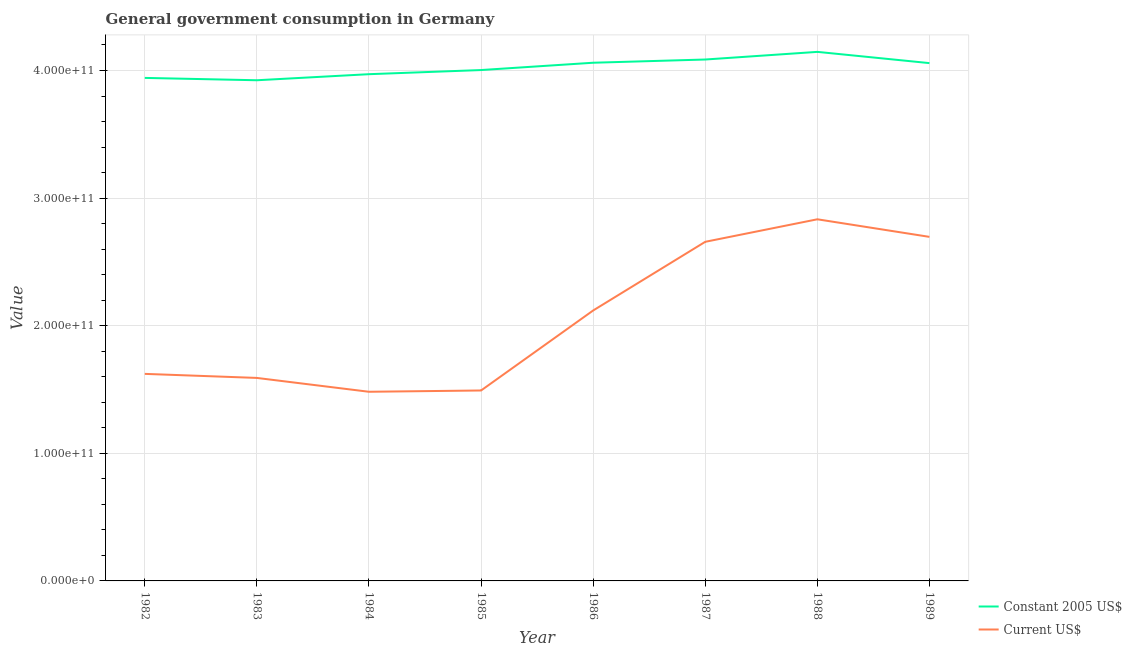Does the line corresponding to value consumed in current us$ intersect with the line corresponding to value consumed in constant 2005 us$?
Your answer should be compact. No. What is the value consumed in current us$ in 1982?
Provide a short and direct response. 1.62e+11. Across all years, what is the maximum value consumed in current us$?
Provide a short and direct response. 2.83e+11. Across all years, what is the minimum value consumed in constant 2005 us$?
Provide a short and direct response. 3.92e+11. What is the total value consumed in current us$ in the graph?
Make the answer very short. 1.65e+12. What is the difference between the value consumed in constant 2005 us$ in 1985 and that in 1986?
Your response must be concise. -5.73e+09. What is the difference between the value consumed in constant 2005 us$ in 1989 and the value consumed in current us$ in 1988?
Your answer should be very brief. 1.22e+11. What is the average value consumed in current us$ per year?
Provide a short and direct response. 2.06e+11. In the year 1986, what is the difference between the value consumed in constant 2005 us$ and value consumed in current us$?
Give a very brief answer. 1.94e+11. What is the ratio of the value consumed in constant 2005 us$ in 1985 to that in 1986?
Provide a short and direct response. 0.99. What is the difference between the highest and the second highest value consumed in current us$?
Provide a succinct answer. 1.38e+1. What is the difference between the highest and the lowest value consumed in current us$?
Your answer should be compact. 1.35e+11. In how many years, is the value consumed in constant 2005 us$ greater than the average value consumed in constant 2005 us$ taken over all years?
Offer a terse response. 4. Is the sum of the value consumed in constant 2005 us$ in 1982 and 1989 greater than the maximum value consumed in current us$ across all years?
Offer a terse response. Yes. How many lines are there?
Offer a very short reply. 2. What is the difference between two consecutive major ticks on the Y-axis?
Give a very brief answer. 1.00e+11. Are the values on the major ticks of Y-axis written in scientific E-notation?
Make the answer very short. Yes. Does the graph contain any zero values?
Provide a succinct answer. No. Where does the legend appear in the graph?
Offer a very short reply. Bottom right. What is the title of the graph?
Your response must be concise. General government consumption in Germany. What is the label or title of the Y-axis?
Provide a succinct answer. Value. What is the Value in Constant 2005 US$ in 1982?
Give a very brief answer. 3.94e+11. What is the Value in Current US$ in 1982?
Your answer should be very brief. 1.62e+11. What is the Value in Constant 2005 US$ in 1983?
Ensure brevity in your answer.  3.92e+11. What is the Value of Current US$ in 1983?
Make the answer very short. 1.59e+11. What is the Value of Constant 2005 US$ in 1984?
Your response must be concise. 3.97e+11. What is the Value in Current US$ in 1984?
Offer a terse response. 1.48e+11. What is the Value in Constant 2005 US$ in 1985?
Ensure brevity in your answer.  4.00e+11. What is the Value of Current US$ in 1985?
Ensure brevity in your answer.  1.49e+11. What is the Value in Constant 2005 US$ in 1986?
Your response must be concise. 4.06e+11. What is the Value in Current US$ in 1986?
Provide a succinct answer. 2.12e+11. What is the Value in Constant 2005 US$ in 1987?
Offer a terse response. 4.09e+11. What is the Value in Current US$ in 1987?
Ensure brevity in your answer.  2.66e+11. What is the Value of Constant 2005 US$ in 1988?
Keep it short and to the point. 4.15e+11. What is the Value in Current US$ in 1988?
Ensure brevity in your answer.  2.83e+11. What is the Value in Constant 2005 US$ in 1989?
Provide a short and direct response. 4.06e+11. What is the Value of Current US$ in 1989?
Give a very brief answer. 2.70e+11. Across all years, what is the maximum Value of Constant 2005 US$?
Your answer should be compact. 4.15e+11. Across all years, what is the maximum Value in Current US$?
Offer a very short reply. 2.83e+11. Across all years, what is the minimum Value of Constant 2005 US$?
Offer a terse response. 3.92e+11. Across all years, what is the minimum Value in Current US$?
Make the answer very short. 1.48e+11. What is the total Value in Constant 2005 US$ in the graph?
Offer a very short reply. 3.22e+12. What is the total Value in Current US$ in the graph?
Your answer should be very brief. 1.65e+12. What is the difference between the Value of Constant 2005 US$ in 1982 and that in 1983?
Your response must be concise. 1.84e+09. What is the difference between the Value in Current US$ in 1982 and that in 1983?
Provide a short and direct response. 3.17e+09. What is the difference between the Value of Constant 2005 US$ in 1982 and that in 1984?
Provide a short and direct response. -2.91e+09. What is the difference between the Value in Current US$ in 1982 and that in 1984?
Your answer should be compact. 1.40e+1. What is the difference between the Value of Constant 2005 US$ in 1982 and that in 1985?
Provide a succinct answer. -6.16e+09. What is the difference between the Value in Current US$ in 1982 and that in 1985?
Provide a short and direct response. 1.30e+1. What is the difference between the Value of Constant 2005 US$ in 1982 and that in 1986?
Make the answer very short. -1.19e+1. What is the difference between the Value of Current US$ in 1982 and that in 1986?
Offer a very short reply. -4.97e+1. What is the difference between the Value in Constant 2005 US$ in 1982 and that in 1987?
Your answer should be very brief. -1.44e+1. What is the difference between the Value in Current US$ in 1982 and that in 1987?
Provide a short and direct response. -1.03e+11. What is the difference between the Value of Constant 2005 US$ in 1982 and that in 1988?
Offer a very short reply. -2.04e+1. What is the difference between the Value in Current US$ in 1982 and that in 1988?
Keep it short and to the point. -1.21e+11. What is the difference between the Value of Constant 2005 US$ in 1982 and that in 1989?
Your answer should be compact. -1.16e+1. What is the difference between the Value in Current US$ in 1982 and that in 1989?
Your answer should be compact. -1.07e+11. What is the difference between the Value in Constant 2005 US$ in 1983 and that in 1984?
Your answer should be very brief. -4.75e+09. What is the difference between the Value of Current US$ in 1983 and that in 1984?
Keep it short and to the point. 1.09e+1. What is the difference between the Value of Constant 2005 US$ in 1983 and that in 1985?
Your answer should be compact. -8.00e+09. What is the difference between the Value in Current US$ in 1983 and that in 1985?
Make the answer very short. 9.84e+09. What is the difference between the Value in Constant 2005 US$ in 1983 and that in 1986?
Offer a terse response. -1.37e+1. What is the difference between the Value in Current US$ in 1983 and that in 1986?
Your response must be concise. -5.29e+1. What is the difference between the Value in Constant 2005 US$ in 1983 and that in 1987?
Offer a very short reply. -1.63e+1. What is the difference between the Value of Current US$ in 1983 and that in 1987?
Your response must be concise. -1.07e+11. What is the difference between the Value of Constant 2005 US$ in 1983 and that in 1988?
Give a very brief answer. -2.22e+1. What is the difference between the Value in Current US$ in 1983 and that in 1988?
Make the answer very short. -1.24e+11. What is the difference between the Value in Constant 2005 US$ in 1983 and that in 1989?
Keep it short and to the point. -1.34e+1. What is the difference between the Value of Current US$ in 1983 and that in 1989?
Your answer should be compact. -1.11e+11. What is the difference between the Value of Constant 2005 US$ in 1984 and that in 1985?
Offer a terse response. -3.25e+09. What is the difference between the Value of Current US$ in 1984 and that in 1985?
Provide a short and direct response. -1.01e+09. What is the difference between the Value in Constant 2005 US$ in 1984 and that in 1986?
Your answer should be compact. -8.98e+09. What is the difference between the Value of Current US$ in 1984 and that in 1986?
Provide a short and direct response. -6.37e+1. What is the difference between the Value in Constant 2005 US$ in 1984 and that in 1987?
Offer a very short reply. -1.15e+1. What is the difference between the Value of Current US$ in 1984 and that in 1987?
Your response must be concise. -1.18e+11. What is the difference between the Value of Constant 2005 US$ in 1984 and that in 1988?
Your answer should be compact. -1.75e+1. What is the difference between the Value in Current US$ in 1984 and that in 1988?
Ensure brevity in your answer.  -1.35e+11. What is the difference between the Value of Constant 2005 US$ in 1984 and that in 1989?
Ensure brevity in your answer.  -8.68e+09. What is the difference between the Value of Current US$ in 1984 and that in 1989?
Ensure brevity in your answer.  -1.21e+11. What is the difference between the Value of Constant 2005 US$ in 1985 and that in 1986?
Provide a succinct answer. -5.73e+09. What is the difference between the Value in Current US$ in 1985 and that in 1986?
Your response must be concise. -6.27e+1. What is the difference between the Value in Constant 2005 US$ in 1985 and that in 1987?
Your answer should be very brief. -8.25e+09. What is the difference between the Value in Current US$ in 1985 and that in 1987?
Your answer should be very brief. -1.17e+11. What is the difference between the Value of Constant 2005 US$ in 1985 and that in 1988?
Offer a very short reply. -1.42e+1. What is the difference between the Value in Current US$ in 1985 and that in 1988?
Keep it short and to the point. -1.34e+11. What is the difference between the Value of Constant 2005 US$ in 1985 and that in 1989?
Keep it short and to the point. -5.43e+09. What is the difference between the Value of Current US$ in 1985 and that in 1989?
Offer a very short reply. -1.20e+11. What is the difference between the Value in Constant 2005 US$ in 1986 and that in 1987?
Your answer should be compact. -2.52e+09. What is the difference between the Value in Current US$ in 1986 and that in 1987?
Make the answer very short. -5.38e+1. What is the difference between the Value of Constant 2005 US$ in 1986 and that in 1988?
Give a very brief answer. -8.51e+09. What is the difference between the Value in Current US$ in 1986 and that in 1988?
Offer a very short reply. -7.15e+1. What is the difference between the Value of Constant 2005 US$ in 1986 and that in 1989?
Keep it short and to the point. 2.99e+08. What is the difference between the Value in Current US$ in 1986 and that in 1989?
Provide a short and direct response. -5.77e+1. What is the difference between the Value in Constant 2005 US$ in 1987 and that in 1988?
Keep it short and to the point. -5.99e+09. What is the difference between the Value of Current US$ in 1987 and that in 1988?
Ensure brevity in your answer.  -1.76e+1. What is the difference between the Value in Constant 2005 US$ in 1987 and that in 1989?
Ensure brevity in your answer.  2.82e+09. What is the difference between the Value in Current US$ in 1987 and that in 1989?
Offer a very short reply. -3.87e+09. What is the difference between the Value of Constant 2005 US$ in 1988 and that in 1989?
Keep it short and to the point. 8.81e+09. What is the difference between the Value in Current US$ in 1988 and that in 1989?
Offer a very short reply. 1.38e+1. What is the difference between the Value of Constant 2005 US$ in 1982 and the Value of Current US$ in 1983?
Make the answer very short. 2.35e+11. What is the difference between the Value of Constant 2005 US$ in 1982 and the Value of Current US$ in 1984?
Provide a succinct answer. 2.46e+11. What is the difference between the Value in Constant 2005 US$ in 1982 and the Value in Current US$ in 1985?
Your answer should be very brief. 2.45e+11. What is the difference between the Value in Constant 2005 US$ in 1982 and the Value in Current US$ in 1986?
Your response must be concise. 1.82e+11. What is the difference between the Value of Constant 2005 US$ in 1982 and the Value of Current US$ in 1987?
Give a very brief answer. 1.28e+11. What is the difference between the Value of Constant 2005 US$ in 1982 and the Value of Current US$ in 1988?
Your answer should be compact. 1.11e+11. What is the difference between the Value in Constant 2005 US$ in 1982 and the Value in Current US$ in 1989?
Your answer should be compact. 1.25e+11. What is the difference between the Value in Constant 2005 US$ in 1983 and the Value in Current US$ in 1984?
Your response must be concise. 2.44e+11. What is the difference between the Value of Constant 2005 US$ in 1983 and the Value of Current US$ in 1985?
Offer a terse response. 2.43e+11. What is the difference between the Value in Constant 2005 US$ in 1983 and the Value in Current US$ in 1986?
Provide a short and direct response. 1.80e+11. What is the difference between the Value in Constant 2005 US$ in 1983 and the Value in Current US$ in 1987?
Keep it short and to the point. 1.27e+11. What is the difference between the Value in Constant 2005 US$ in 1983 and the Value in Current US$ in 1988?
Offer a terse response. 1.09e+11. What is the difference between the Value in Constant 2005 US$ in 1983 and the Value in Current US$ in 1989?
Provide a short and direct response. 1.23e+11. What is the difference between the Value in Constant 2005 US$ in 1984 and the Value in Current US$ in 1985?
Provide a short and direct response. 2.48e+11. What is the difference between the Value in Constant 2005 US$ in 1984 and the Value in Current US$ in 1986?
Make the answer very short. 1.85e+11. What is the difference between the Value of Constant 2005 US$ in 1984 and the Value of Current US$ in 1987?
Make the answer very short. 1.31e+11. What is the difference between the Value of Constant 2005 US$ in 1984 and the Value of Current US$ in 1988?
Offer a terse response. 1.14e+11. What is the difference between the Value in Constant 2005 US$ in 1984 and the Value in Current US$ in 1989?
Make the answer very short. 1.27e+11. What is the difference between the Value in Constant 2005 US$ in 1985 and the Value in Current US$ in 1986?
Ensure brevity in your answer.  1.88e+11. What is the difference between the Value of Constant 2005 US$ in 1985 and the Value of Current US$ in 1987?
Keep it short and to the point. 1.35e+11. What is the difference between the Value in Constant 2005 US$ in 1985 and the Value in Current US$ in 1988?
Make the answer very short. 1.17e+11. What is the difference between the Value in Constant 2005 US$ in 1985 and the Value in Current US$ in 1989?
Your response must be concise. 1.31e+11. What is the difference between the Value of Constant 2005 US$ in 1986 and the Value of Current US$ in 1987?
Your response must be concise. 1.40e+11. What is the difference between the Value in Constant 2005 US$ in 1986 and the Value in Current US$ in 1988?
Offer a terse response. 1.23e+11. What is the difference between the Value in Constant 2005 US$ in 1986 and the Value in Current US$ in 1989?
Offer a terse response. 1.36e+11. What is the difference between the Value of Constant 2005 US$ in 1987 and the Value of Current US$ in 1988?
Make the answer very short. 1.25e+11. What is the difference between the Value in Constant 2005 US$ in 1987 and the Value in Current US$ in 1989?
Offer a very short reply. 1.39e+11. What is the difference between the Value in Constant 2005 US$ in 1988 and the Value in Current US$ in 1989?
Keep it short and to the point. 1.45e+11. What is the average Value of Constant 2005 US$ per year?
Provide a succinct answer. 4.02e+11. What is the average Value of Current US$ per year?
Offer a terse response. 2.06e+11. In the year 1982, what is the difference between the Value in Constant 2005 US$ and Value in Current US$?
Provide a succinct answer. 2.32e+11. In the year 1983, what is the difference between the Value of Constant 2005 US$ and Value of Current US$?
Your response must be concise. 2.33e+11. In the year 1984, what is the difference between the Value of Constant 2005 US$ and Value of Current US$?
Your response must be concise. 2.49e+11. In the year 1985, what is the difference between the Value of Constant 2005 US$ and Value of Current US$?
Offer a terse response. 2.51e+11. In the year 1986, what is the difference between the Value in Constant 2005 US$ and Value in Current US$?
Offer a very short reply. 1.94e+11. In the year 1987, what is the difference between the Value in Constant 2005 US$ and Value in Current US$?
Your answer should be compact. 1.43e+11. In the year 1988, what is the difference between the Value in Constant 2005 US$ and Value in Current US$?
Offer a very short reply. 1.31e+11. In the year 1989, what is the difference between the Value of Constant 2005 US$ and Value of Current US$?
Keep it short and to the point. 1.36e+11. What is the ratio of the Value of Current US$ in 1982 to that in 1983?
Provide a succinct answer. 1.02. What is the ratio of the Value of Constant 2005 US$ in 1982 to that in 1984?
Provide a succinct answer. 0.99. What is the ratio of the Value in Current US$ in 1982 to that in 1984?
Ensure brevity in your answer.  1.09. What is the ratio of the Value of Constant 2005 US$ in 1982 to that in 1985?
Offer a very short reply. 0.98. What is the ratio of the Value of Current US$ in 1982 to that in 1985?
Provide a short and direct response. 1.09. What is the ratio of the Value in Constant 2005 US$ in 1982 to that in 1986?
Your answer should be compact. 0.97. What is the ratio of the Value of Current US$ in 1982 to that in 1986?
Provide a succinct answer. 0.77. What is the ratio of the Value of Constant 2005 US$ in 1982 to that in 1987?
Your response must be concise. 0.96. What is the ratio of the Value of Current US$ in 1982 to that in 1987?
Your response must be concise. 0.61. What is the ratio of the Value in Constant 2005 US$ in 1982 to that in 1988?
Make the answer very short. 0.95. What is the ratio of the Value of Current US$ in 1982 to that in 1988?
Ensure brevity in your answer.  0.57. What is the ratio of the Value in Constant 2005 US$ in 1982 to that in 1989?
Give a very brief answer. 0.97. What is the ratio of the Value in Current US$ in 1982 to that in 1989?
Offer a very short reply. 0.6. What is the ratio of the Value in Constant 2005 US$ in 1983 to that in 1984?
Your answer should be compact. 0.99. What is the ratio of the Value of Current US$ in 1983 to that in 1984?
Ensure brevity in your answer.  1.07. What is the ratio of the Value in Constant 2005 US$ in 1983 to that in 1985?
Ensure brevity in your answer.  0.98. What is the ratio of the Value of Current US$ in 1983 to that in 1985?
Provide a succinct answer. 1.07. What is the ratio of the Value of Constant 2005 US$ in 1983 to that in 1986?
Provide a succinct answer. 0.97. What is the ratio of the Value in Current US$ in 1983 to that in 1986?
Provide a short and direct response. 0.75. What is the ratio of the Value in Constant 2005 US$ in 1983 to that in 1987?
Your answer should be very brief. 0.96. What is the ratio of the Value of Current US$ in 1983 to that in 1987?
Provide a short and direct response. 0.6. What is the ratio of the Value of Constant 2005 US$ in 1983 to that in 1988?
Make the answer very short. 0.95. What is the ratio of the Value of Current US$ in 1983 to that in 1988?
Offer a terse response. 0.56. What is the ratio of the Value in Constant 2005 US$ in 1983 to that in 1989?
Your response must be concise. 0.97. What is the ratio of the Value in Current US$ in 1983 to that in 1989?
Provide a short and direct response. 0.59. What is the ratio of the Value in Constant 2005 US$ in 1984 to that in 1985?
Offer a terse response. 0.99. What is the ratio of the Value of Current US$ in 1984 to that in 1985?
Your answer should be very brief. 0.99. What is the ratio of the Value in Constant 2005 US$ in 1984 to that in 1986?
Offer a terse response. 0.98. What is the ratio of the Value of Current US$ in 1984 to that in 1986?
Make the answer very short. 0.7. What is the ratio of the Value of Constant 2005 US$ in 1984 to that in 1987?
Your answer should be very brief. 0.97. What is the ratio of the Value of Current US$ in 1984 to that in 1987?
Offer a terse response. 0.56. What is the ratio of the Value of Constant 2005 US$ in 1984 to that in 1988?
Make the answer very short. 0.96. What is the ratio of the Value of Current US$ in 1984 to that in 1988?
Make the answer very short. 0.52. What is the ratio of the Value in Constant 2005 US$ in 1984 to that in 1989?
Provide a succinct answer. 0.98. What is the ratio of the Value of Current US$ in 1984 to that in 1989?
Keep it short and to the point. 0.55. What is the ratio of the Value in Constant 2005 US$ in 1985 to that in 1986?
Offer a very short reply. 0.99. What is the ratio of the Value in Current US$ in 1985 to that in 1986?
Provide a short and direct response. 0.7. What is the ratio of the Value of Constant 2005 US$ in 1985 to that in 1987?
Ensure brevity in your answer.  0.98. What is the ratio of the Value in Current US$ in 1985 to that in 1987?
Ensure brevity in your answer.  0.56. What is the ratio of the Value of Constant 2005 US$ in 1985 to that in 1988?
Provide a succinct answer. 0.97. What is the ratio of the Value in Current US$ in 1985 to that in 1988?
Give a very brief answer. 0.53. What is the ratio of the Value in Constant 2005 US$ in 1985 to that in 1989?
Provide a short and direct response. 0.99. What is the ratio of the Value of Current US$ in 1985 to that in 1989?
Keep it short and to the point. 0.55. What is the ratio of the Value in Current US$ in 1986 to that in 1987?
Keep it short and to the point. 0.8. What is the ratio of the Value in Constant 2005 US$ in 1986 to that in 1988?
Keep it short and to the point. 0.98. What is the ratio of the Value in Current US$ in 1986 to that in 1988?
Keep it short and to the point. 0.75. What is the ratio of the Value in Constant 2005 US$ in 1986 to that in 1989?
Your answer should be compact. 1. What is the ratio of the Value of Current US$ in 1986 to that in 1989?
Offer a terse response. 0.79. What is the ratio of the Value of Constant 2005 US$ in 1987 to that in 1988?
Ensure brevity in your answer.  0.99. What is the ratio of the Value in Current US$ in 1987 to that in 1988?
Offer a terse response. 0.94. What is the ratio of the Value of Current US$ in 1987 to that in 1989?
Offer a very short reply. 0.99. What is the ratio of the Value in Constant 2005 US$ in 1988 to that in 1989?
Your answer should be compact. 1.02. What is the ratio of the Value of Current US$ in 1988 to that in 1989?
Offer a terse response. 1.05. What is the difference between the highest and the second highest Value in Constant 2005 US$?
Your response must be concise. 5.99e+09. What is the difference between the highest and the second highest Value in Current US$?
Your answer should be compact. 1.38e+1. What is the difference between the highest and the lowest Value in Constant 2005 US$?
Give a very brief answer. 2.22e+1. What is the difference between the highest and the lowest Value in Current US$?
Offer a terse response. 1.35e+11. 